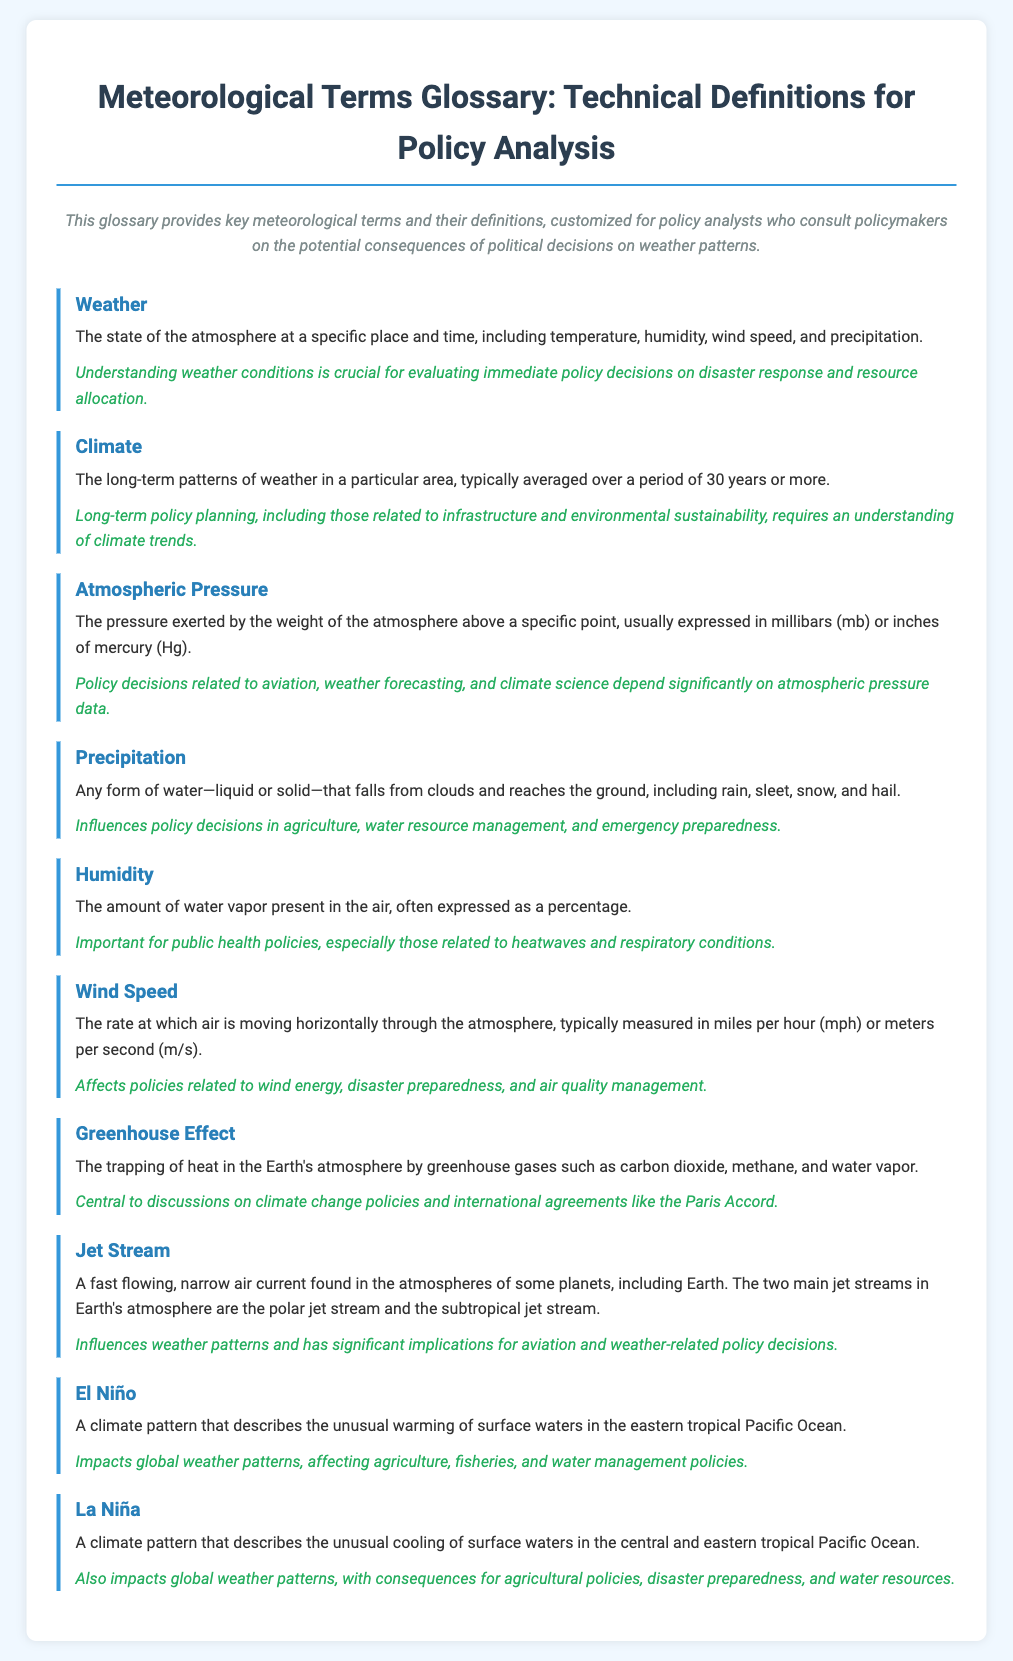What is the definition of weather? The definition of weather is provided in the glossary, describing it as the state of the atmosphere at a specific place and time, including temperature, humidity, wind speed, and precipitation.
Answer: The state of the atmosphere at a specific place and time, including temperature, humidity, wind speed, and precipitation What does humidity measure? Humidity measures the amount of water vapor present in the air, often expressed as a percentage.
Answer: The amount of water vapor present in the air What are the two main types of jet streams mentioned? The glossary mentions the polar jet stream and the subtropical jet stream as the two main types of jet streams.
Answer: Polar jet stream and subtropical jet stream What is the relevance of precipitation in policy decisions? The glossary states that precipitation influences policy decisions in agriculture, water resource management, and emergency preparedness.
Answer: Agriculture, water resource management, and emergency preparedness How long is the period typically considered for averaging climate data? The glossary explains that climate data is typically averaged over a period of 30 years or more.
Answer: 30 years or more What phenomenon describes the unusual warming of surface waters in the eastern Pacific? The glossary defines El Niño as the climate pattern that describes this phenomenon.
Answer: El Niño What is the effect of the greenhouse effect on political discussions? The glossary mentions the greenhouse effect as central to discussions on climate change policies and international agreements like the Paris Accord.
Answer: Climate change policies and international agreements like the Paris Accord What does wind speed affect in terms of policy? Wind speed affects policies related to wind energy, disaster preparedness, and air quality management.
Answer: Wind energy, disaster preparedness, and air quality management 